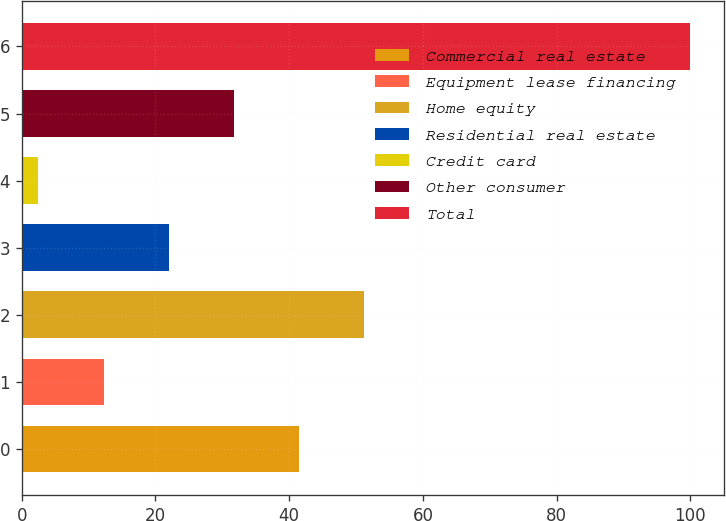<chart> <loc_0><loc_0><loc_500><loc_500><bar_chart><fcel>Commercial real estate<fcel>Equipment lease financing<fcel>Home equity<fcel>Residential real estate<fcel>Credit card<fcel>Other consumer<fcel>Total<nl><fcel>41.5<fcel>12.25<fcel>51.25<fcel>22<fcel>2.5<fcel>31.75<fcel>100<nl></chart> 